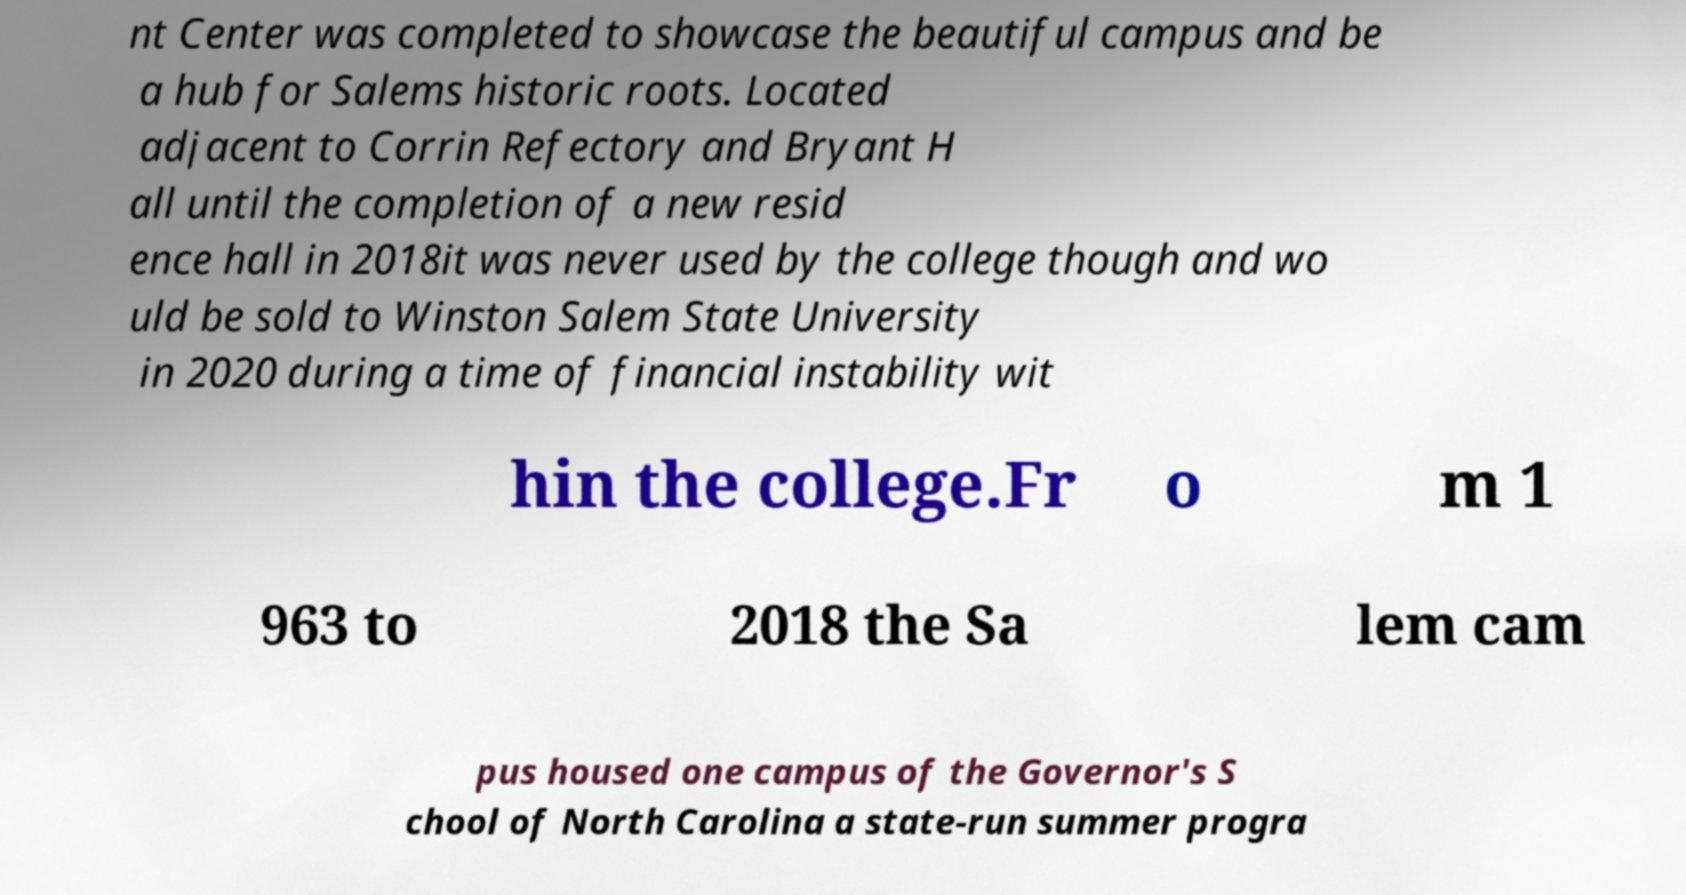Could you extract and type out the text from this image? nt Center was completed to showcase the beautiful campus and be a hub for Salems historic roots. Located adjacent to Corrin Refectory and Bryant H all until the completion of a new resid ence hall in 2018it was never used by the college though and wo uld be sold to Winston Salem State University in 2020 during a time of financial instability wit hin the college.Fr o m 1 963 to 2018 the Sa lem cam pus housed one campus of the Governor's S chool of North Carolina a state-run summer progra 